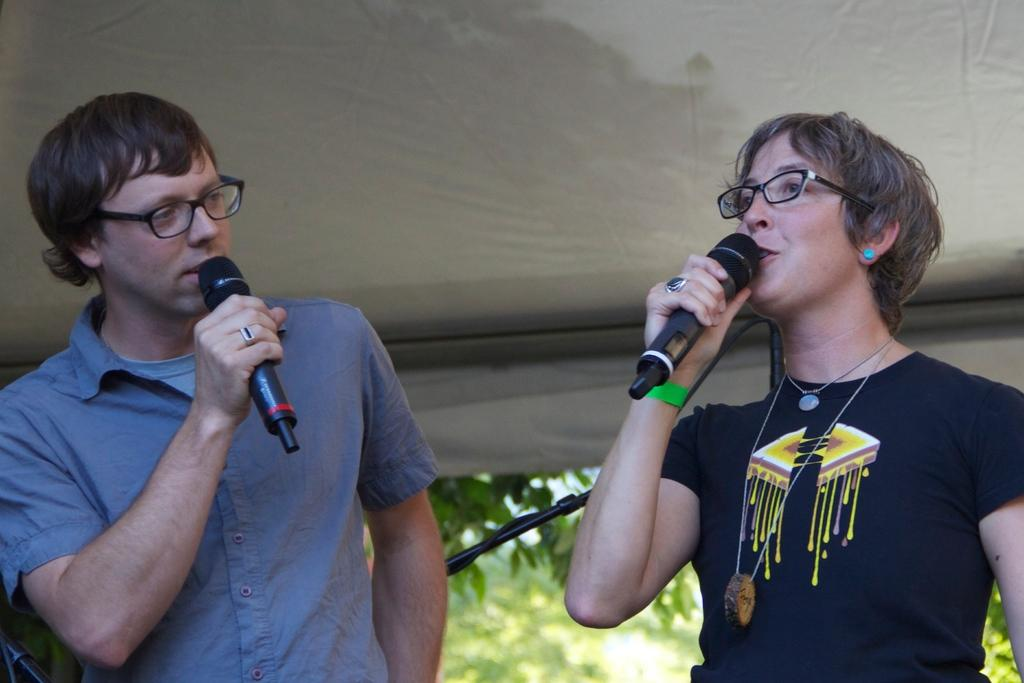Who is present in the image? There is a man and a woman in the image. What are the man and the woman holding? They are both holding microphones. What can be observed about their appearance? The man and the woman are wearing glasses. What might they be doing in the image? They appear to be talking. What can be seen in the background of the image? There is a fabric roof and trees in the background. What type of oil can be seen dripping from the trees in the background? There is no oil present in the image; the trees in the background are not depicted as dripping any substance. 